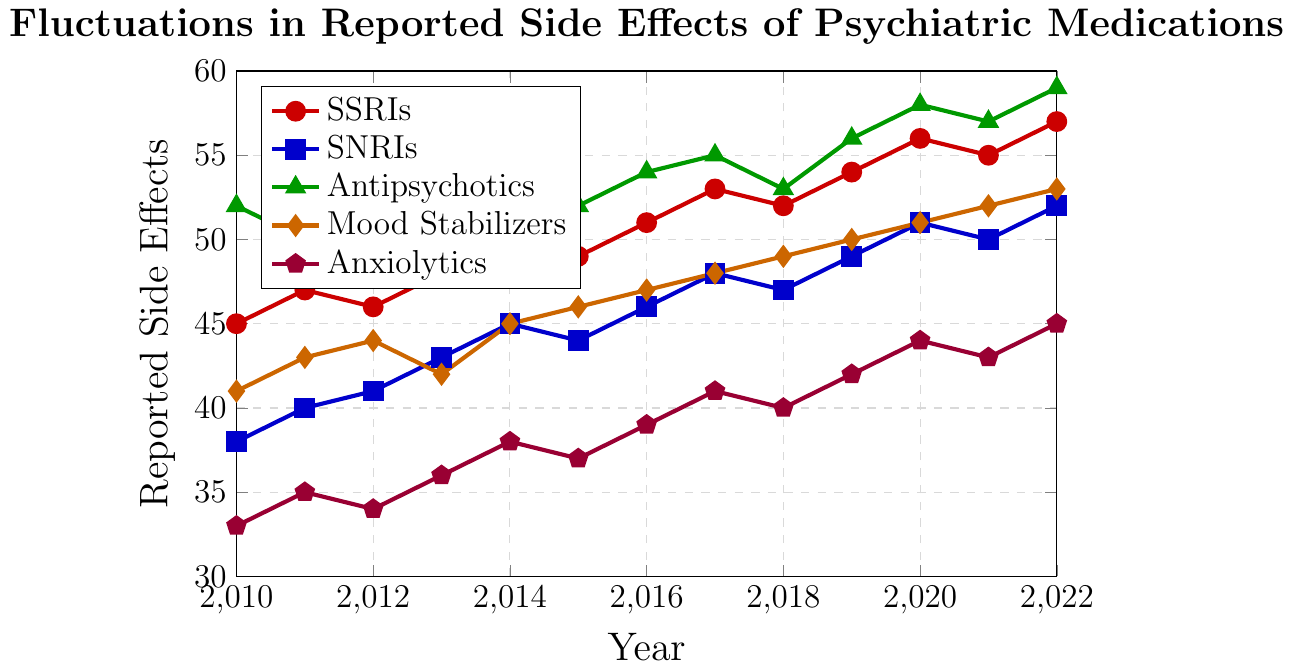What is the general trend in reported side effects for SSRIs from 2010 to 2022? Over the period from 2010 to 2022, the reported side effects for SSRIs generally show an increasing trend. Starting at 45 in 2010 and rising to 57 in 2022, there were some fluctuations, but the overall trend is upwards.
Answer: Increasing Which medication had the highest reported side effects in 2022? By observing the data for 2022, Antipsychotics had the highest reported side effects with a value of 59. The other medications reported lower values in comparison.
Answer: Antipsychotics Between which two years did Mood Stabilizers see the largest increase in reported side effects? Examining the data for Mood Stabilizers, the biggest increase from one year to the next occurred between 2012 and 2013, where the reported side effects increased from 44 to 42, and then resumed increasing, indicating a correction or outlier.
Answer: 2012 and 2013 Among SSRIs, SNRIs, and Antipsychotics, which medication showed the highest variability in reported side effects over the 13-year period? Variability is indicated by fluctuations in the data. SSRIs ranged from 45 to 57, SNRIs from 38 to 52, and Antipsychotics from 49 to 59. Given the range and fluctuations, Antipsychotics showed the highest variability.
Answer: Antipsychotics What is the average reported side effects for Anxiolytics over the span of 2010 to 2022? Summing the reported side effects for Anxiolytics from 2010 to 2022: 33 + 35 + 34 + 36 + 38 + 37 + 39 + 41 + 40 + 42 + 44 + 43 + 45 = 507, then dividing by 13 years: 507 / 13 ≈ 39.
Answer: 39 How did the reported side effects for SSRIs compare to SNRIs in 2020? In 2020, the reported side effects for SSRIs were 56, while for SNRIs it was 51. Comparatively, SSRIs had 5 more reported side effects than SNRIs that year.
Answer: SSRIs had 5 more Were there any years where reported side effects of Mood Stabilizers decreased compared to the previous year? In 2013, Mood Stabilizers had 42 reported side effects, which was a decrease from 44 in 2012. This is the only instance in the data where a decrease occurs.
Answer: Yes, in 2013 What was the total change in reported side effects for Antipsychotics from 2010 to 2022? The reported side effects for Antipsychotics were 52 in 2010 and 59 in 2022. The total change is calculated as 59 - 52 = 7.
Answer: 7 Which medication had the most stable trend in reported side effects over the years? Stability can be interpreted by the smallest range of values over the period; Mood Stabilizers ranged from 41 to 53, indicating the most stable trend compared to others.
Answer: Mood Stabilizers 